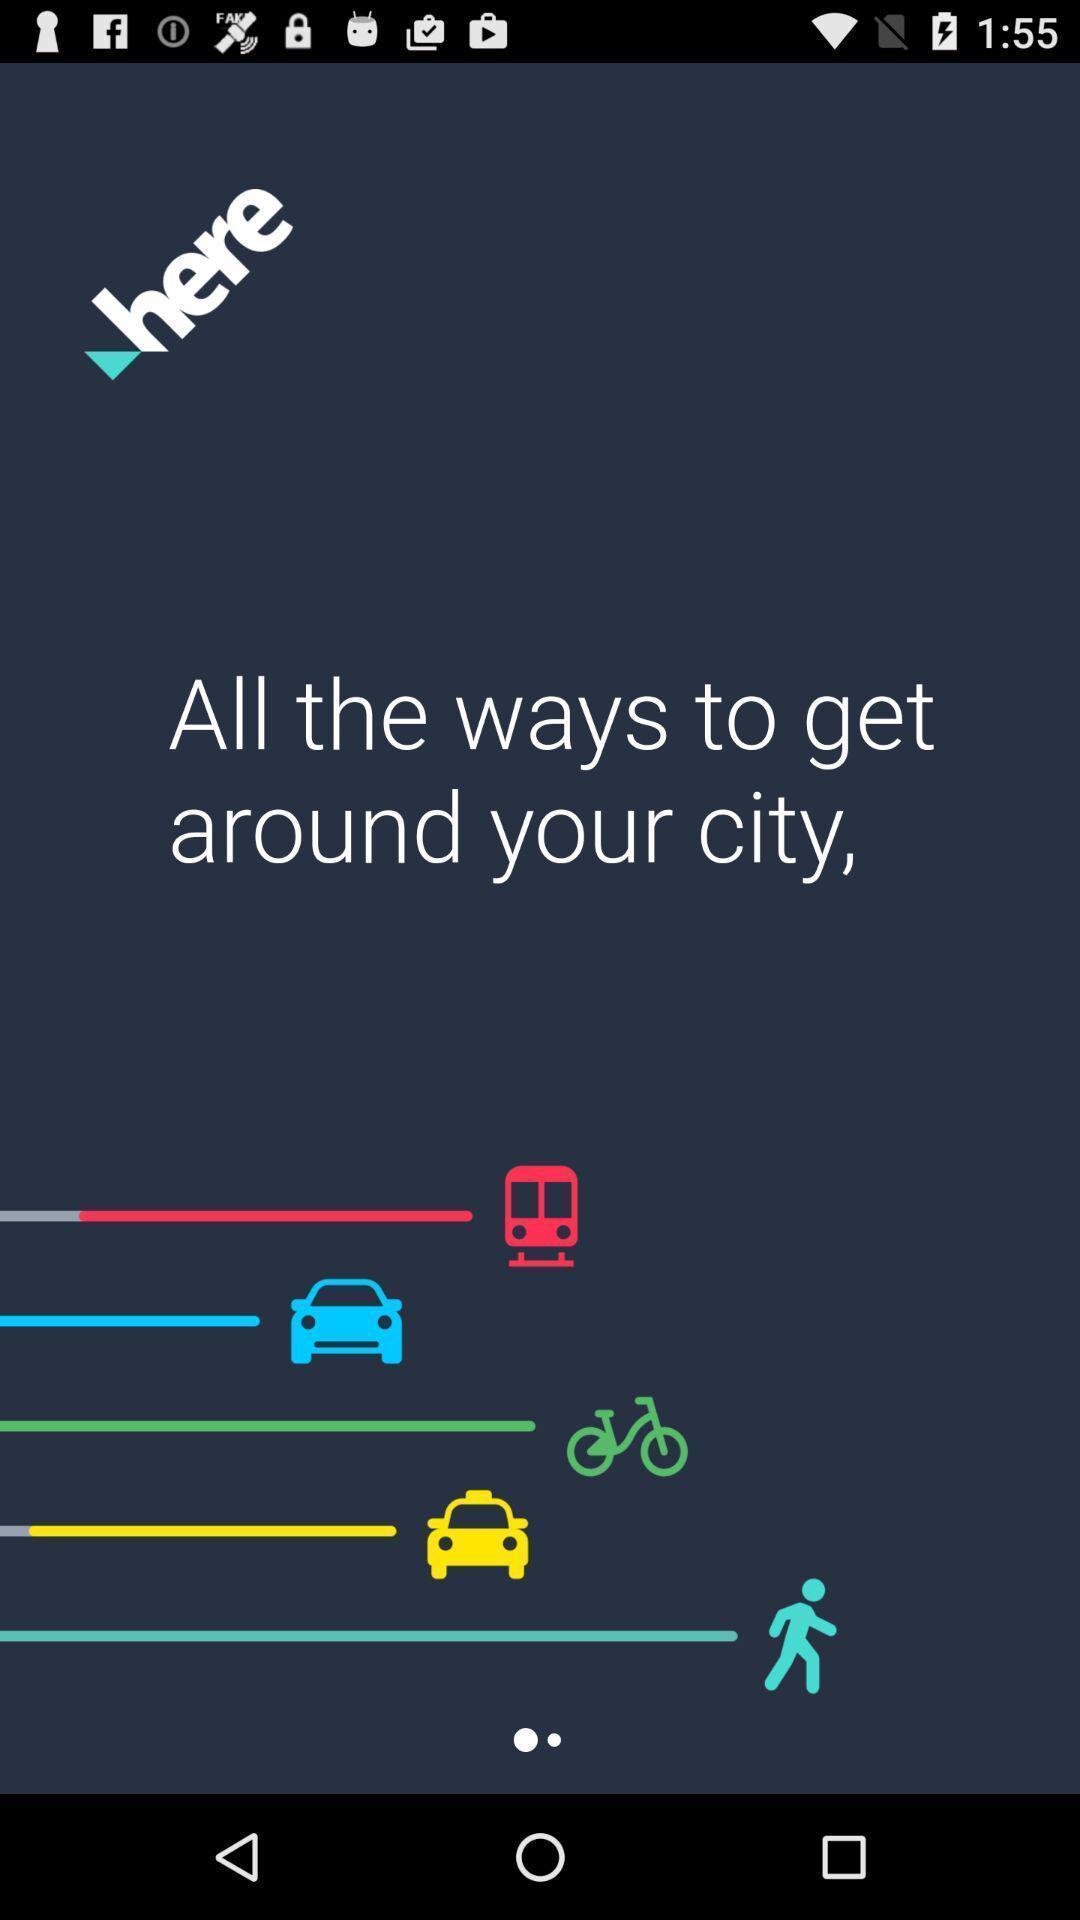Summarize the information in this screenshot. Welcome page of a travel application. 